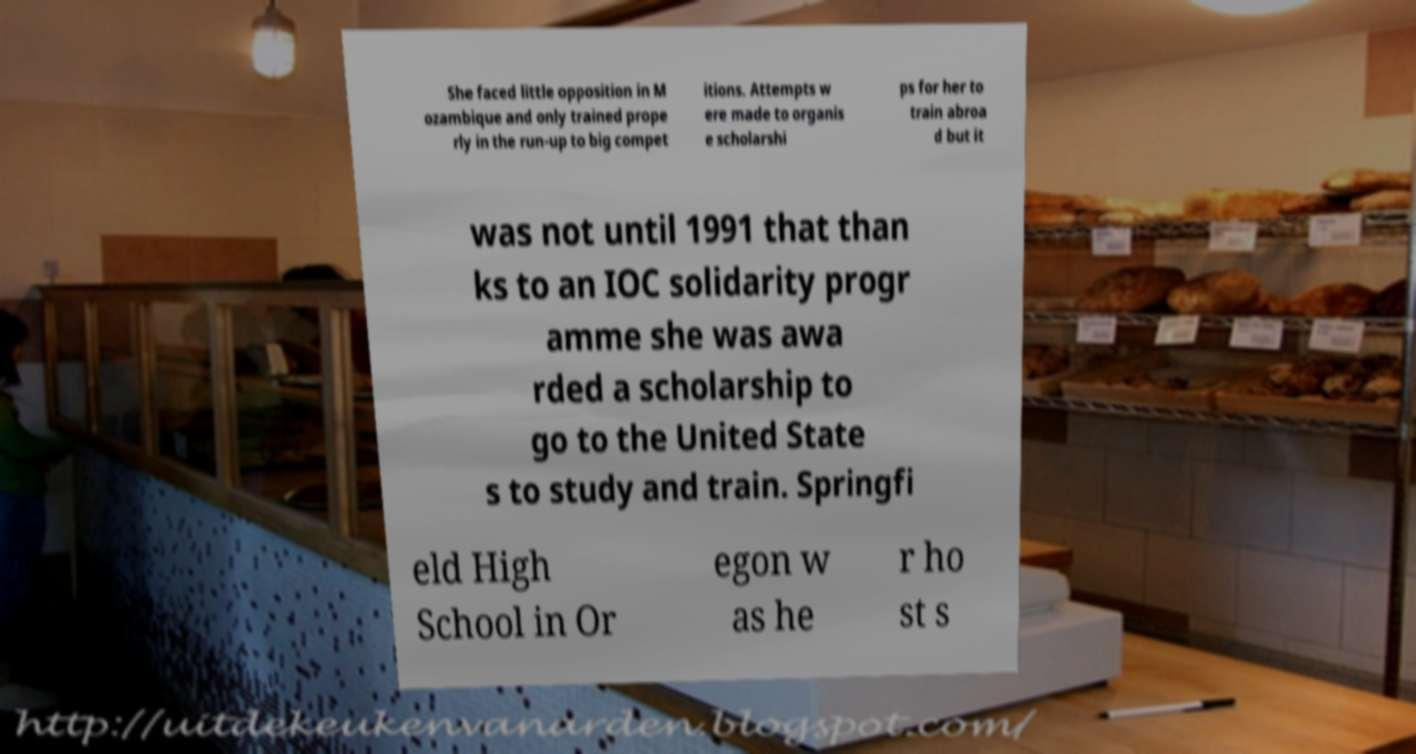Please read and relay the text visible in this image. What does it say? She faced little opposition in M ozambique and only trained prope rly in the run-up to big compet itions. Attempts w ere made to organis e scholarshi ps for her to train abroa d but it was not until 1991 that than ks to an IOC solidarity progr amme she was awa rded a scholarship to go to the United State s to study and train. Springfi eld High School in Or egon w as he r ho st s 